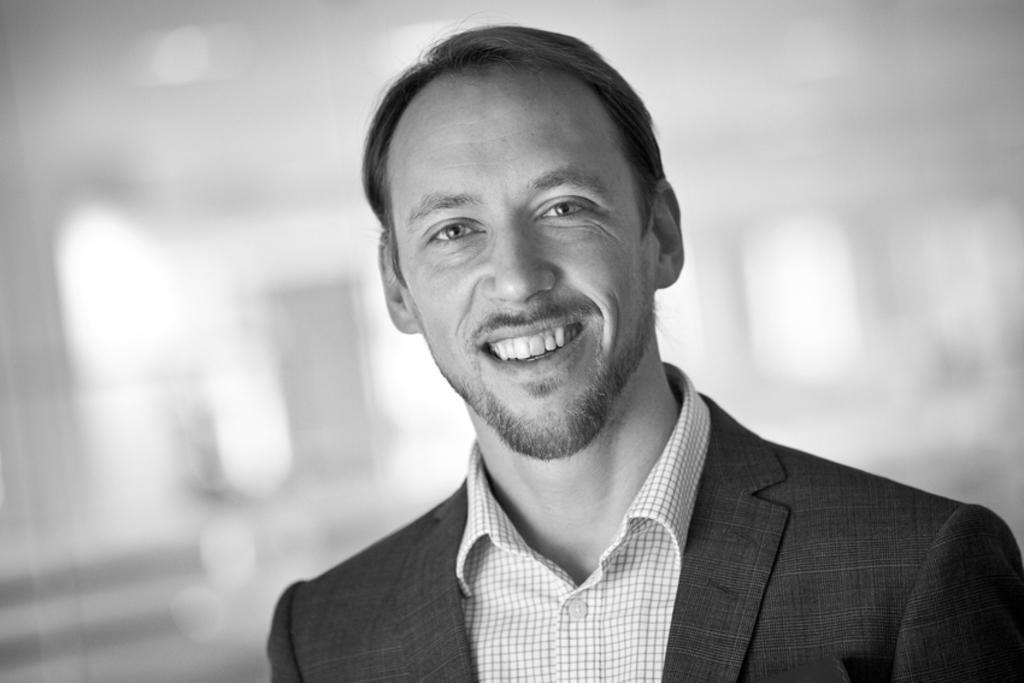What is the color scheme of the image? The image is in black and white. Who is the main subject in the image? There is a man in the center of the image. What type of clothing is the man wearing? The man is wearing a blazer and a shirt. What type of authority does the man in the image have over the square? There is no mention of a square or any authority in the image. The image only shows a man wearing a blazer and a shirt in a black and white setting. 